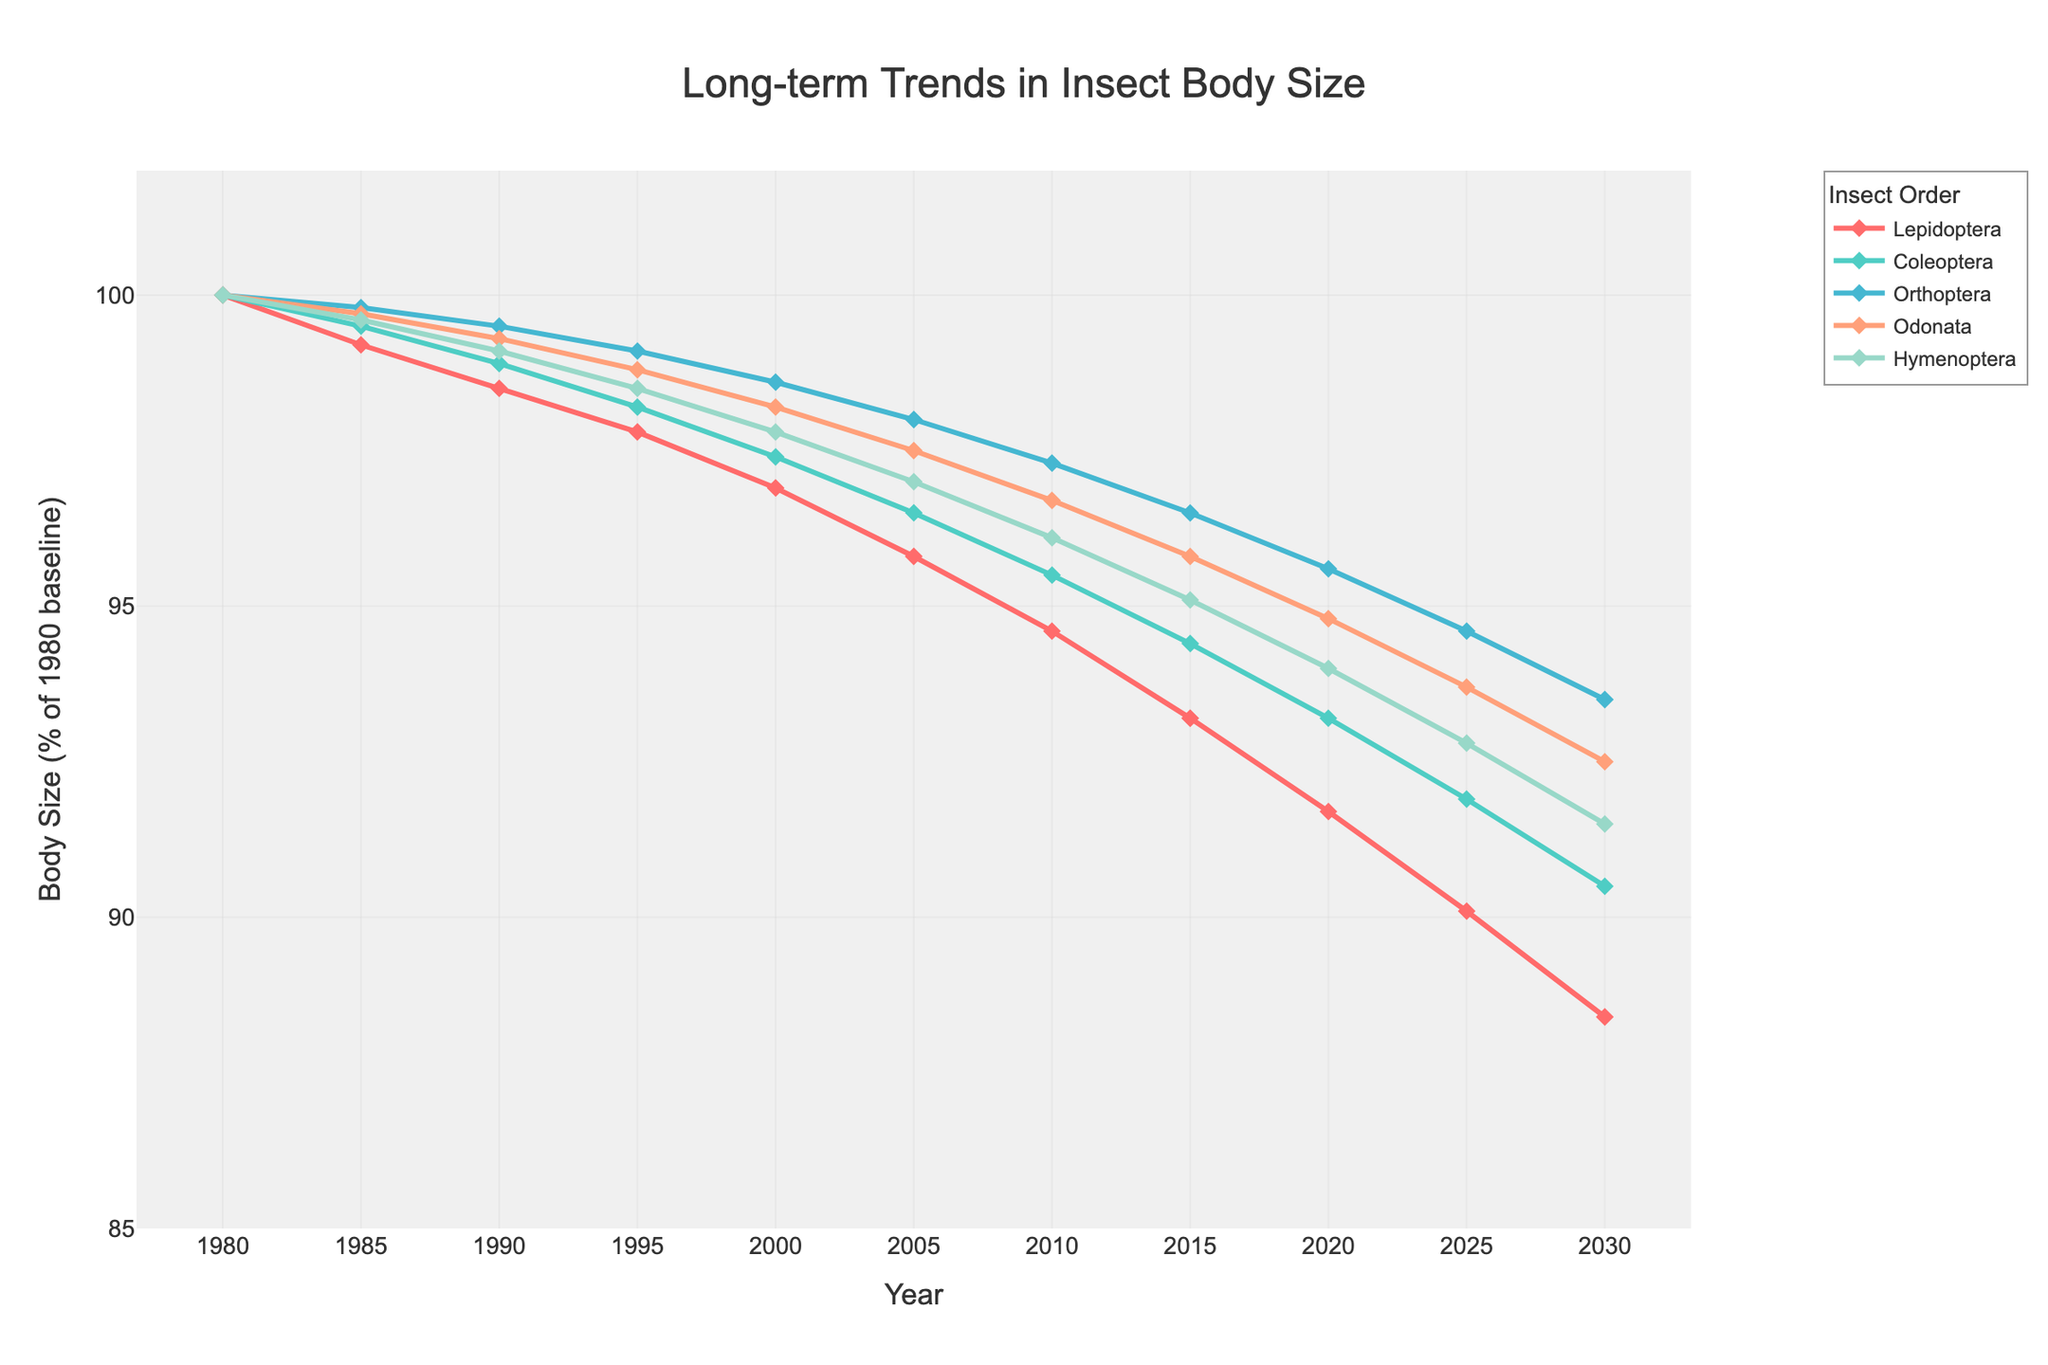Which insect order shows the largest decline in body size from 1980 to 2030? To determine the largest decline, look at the body size percentages for each insect order in 1980 and 2030. Calculate the difference for each order: Lepidoptera (100 - 88.4 = 11.6), Coleoptera (100 - 90.5 = 9.5), Orthoptera (100 - 93.5 = 6.5), Odonata (100 - 92.5 = 7.5), Hymenoptera (100 - 91.5 = 8.5). Lepidoptera has the largest decline of 11.6%.
Answer: Lepidoptera Which insect order has consistently shown the smallest decline in body size over the years? To find the insect order with the smallest decline over the years, compare the trend lines of each order from 1980 to 2030. Orthoptera shows the smallest decline, from 100% to 93.5%, a total decline of 6.5%.
Answer: Orthoptera During which five-year interval did Lepidoptera experience the steepest decline in body size? Examine the data points for Lepidoptera to determine the steepest decline by calculating the differences for each interval: 1980-1985 (100 - 99.2 = 0.8), 1985-1990 (99.2 - 98.5 = 0.7), 1990-1995 (98.5 - 97.8 = 0.7), 1995-2000 (97.8 - 96.9 = 0.9), 2000-2005 (96.9 - 95.8 = 1.1), 2005-2010 (95.8 - 94.6 = 1.2), 2010-2015 (94.6 - 93.2 = 1.4), 2015-2020 (93.2 - 91.7 = 1.5), 2020-2025 (91.7 - 90.1 = 1.6), 2025-2030 (90.1 - 88.4 = 1.7). The steepest decline occurs between 2025 and 2030 (1.7).
Answer: 2025-2030 Which insect order has the highest body size percentage in 2020? Look at the data for 2020 and compare the body size percentages for each order: Lepidoptera (91.7), Coleoptera (93.2), Orthoptera (95.6), Odonata (94.8), Hymenoptera (94.0). Orthoptera has the highest body size percentage at 95.6%.
Answer: Orthoptera What is the average body size percentage of Hymenoptera from 1980 to 2030? Sum the body size percentages of Hymenoptera for each year and divide by the number of data points: (100 + 99.6 + 99.1 + 98.5 + 97.8 + 97.0 + 96.1 + 95.1 + 94.0 + 92.8 + 91.5) = 1060.4. The average is 1060.4 / 11 ≈ 96.4.
Answer: 96.4 Between which years did all insect orders show an overall downward trend? To determine this, look for a consistent decrease in all insect orders during specific periods. Between each interval from 1980 to 2030, all orders show a continuous decline in body size.
Answer: 1980-2030 